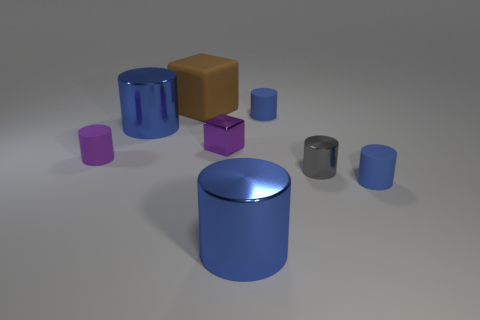Do the tiny block and the tiny rubber cylinder that is on the left side of the brown block have the same color?
Ensure brevity in your answer.  Yes. What number of cylinders have the same color as the metal cube?
Give a very brief answer. 1. What material is the small gray cylinder that is right of the tiny cylinder that is behind the tiny rubber cylinder to the left of the brown object?
Keep it short and to the point. Metal. What number of shiny things are small purple things or tiny yellow objects?
Provide a succinct answer. 1. Are there any big rubber cubes?
Give a very brief answer. Yes. What is the color of the large shiny cylinder that is behind the cylinder to the right of the tiny gray metal thing?
Make the answer very short. Blue. How many other objects are the same color as the tiny shiny cube?
Ensure brevity in your answer.  1. What number of things are red metal cylinders or blue shiny objects on the right side of the brown matte cube?
Provide a short and direct response. 1. What color is the block that is to the right of the brown block?
Your answer should be very brief. Purple. The purple rubber object is what shape?
Your answer should be compact. Cylinder. 